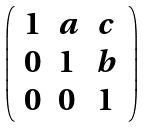<formula> <loc_0><loc_0><loc_500><loc_500>\left ( \begin{array} { l l l } { 1 } & { a } & { c } \\ { 0 } & { 1 } & { b } \\ { 0 } & { 0 } & { 1 } \end{array} \right )</formula> 